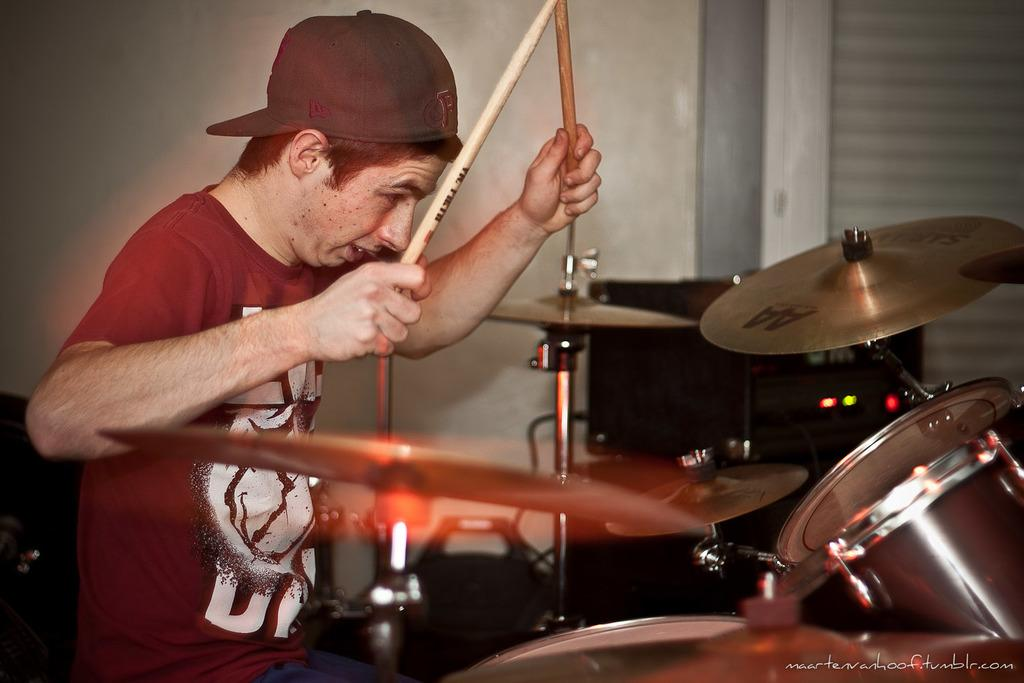What is the person in the image doing? The person is sitting on a chair and playing a musical instrument. What objects does the person hold while playing the instrument? The person holds sticks and a wire cap. Are there any electronic devices visible in the image? Yes, there are electronic devices present. How does the person create a thrilling atmosphere with their musical performance in the image? The image does not provide information about the person's musical performance or the atmosphere it creates. 